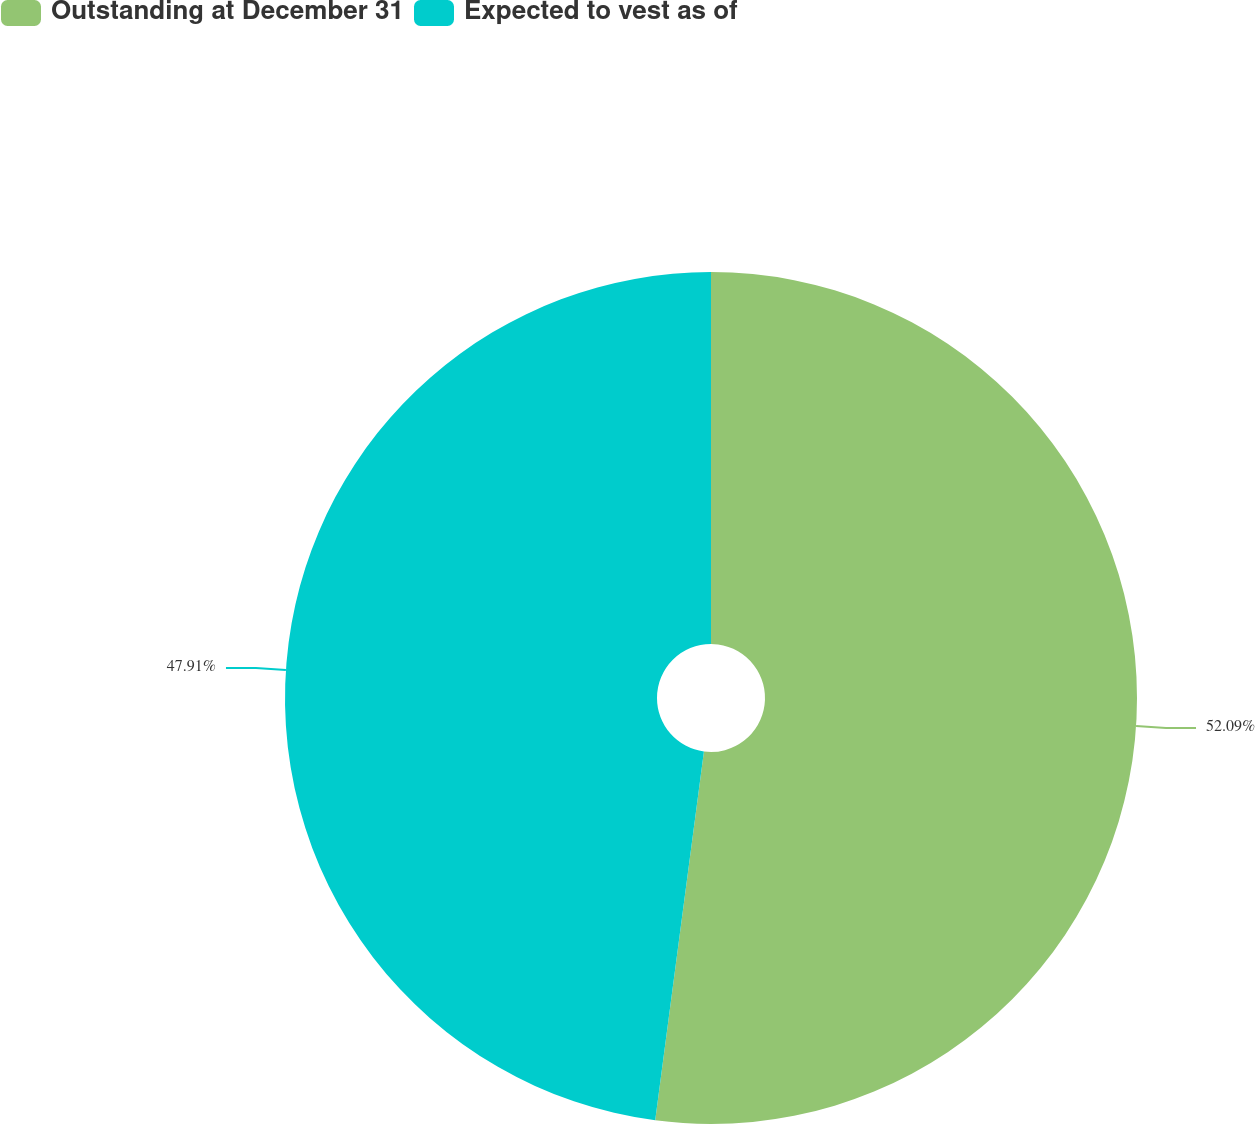Convert chart. <chart><loc_0><loc_0><loc_500><loc_500><pie_chart><fcel>Outstanding at December 31<fcel>Expected to vest as of<nl><fcel>52.09%<fcel>47.91%<nl></chart> 